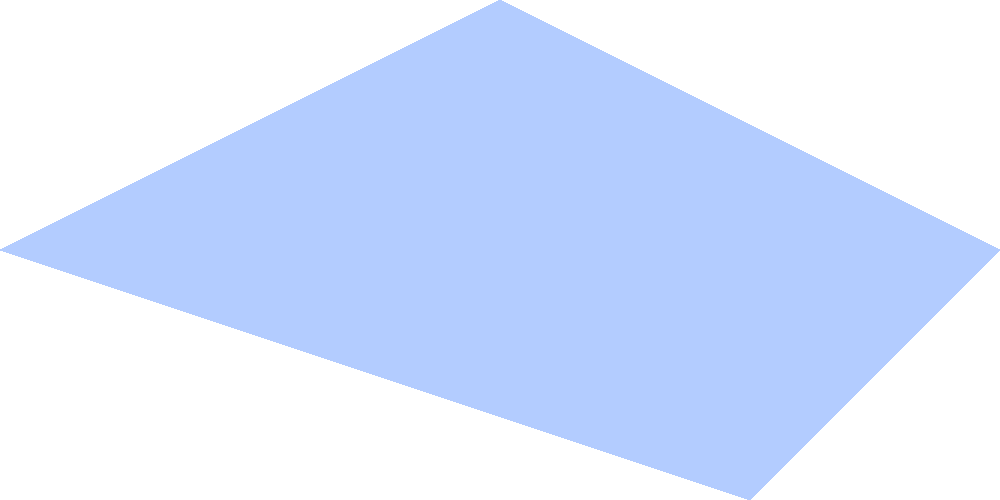In which famous Finnish horror film location does this aerial photograph likely depict? To identify this location, let's analyze the key elements in the aerial photograph:

1. Large body of water: The image shows a significant blue area, indicating a lake.
2. Surrounding forest: Green dots represent a dense forest area around the lake.
3. Small structure: A brown rectangle near the lake suggests a cabin or small building.
4. Road: A gray line indicates a road running near the lake and cabin.
5. Lake name: The label "Päijänne" identifies the lake in the image.

These elements point to a specific location that is iconic in Finnish horror cinema:

- Lake Päijänne is Finland's second-largest lake and a popular setting for films.
- The combination of a remote cabin near a large lake surrounded by forest is a classic horror movie setting.
- This particular layout strongly resembles the location used in the cult Finnish horror film "Sauna" (2008), directed by Antti-Jussi Annila.

"Sauna" is set in the 16th century and features a small group of men who encounter a mysterious sauna in the forest near a lake. The film's atmospheric and eerie use of the Finnish landscape, particularly the isolated cabin by the lake, makes it a standout in Finnish horror cinema.
Answer: "Sauna" (2008) film location 